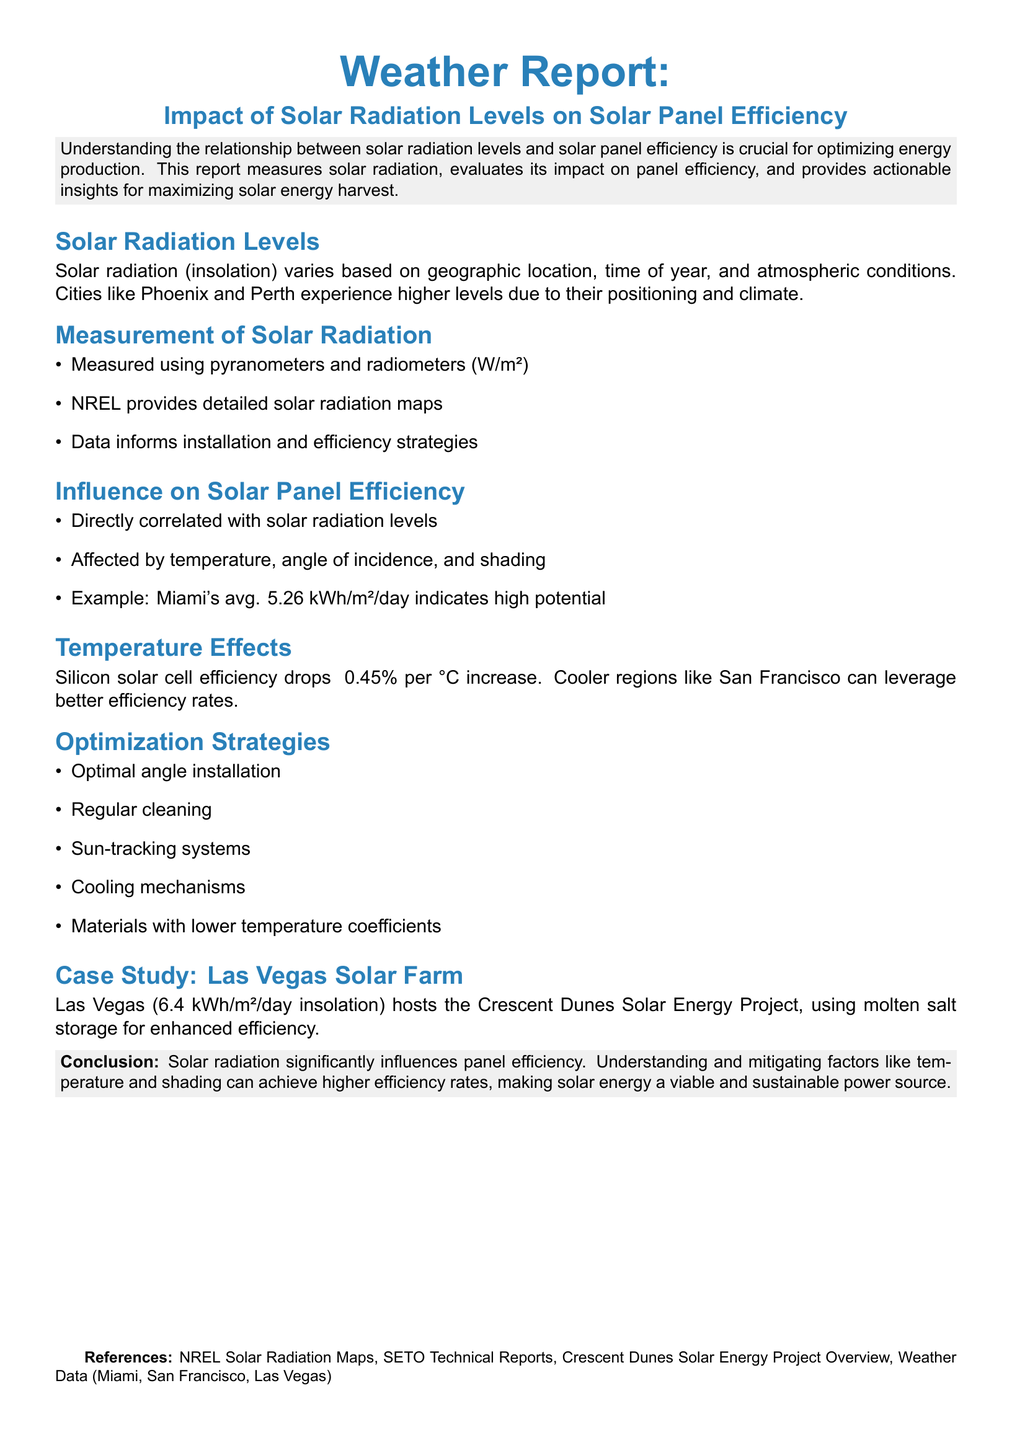What is the primary focus of the report? The report primarily focuses on understanding the relationship between solar radiation levels and solar panel efficiency.
Answer: Solar radiation levels and solar panel efficiency What measurement instruments are used for solar radiation? The document states that solar radiation is measured using pyranometers and radiometers.
Answer: Pyranometers and radiometers Which city has an average insolation of 5.26 kWh/m²/day? The report mentions that Miami's average insolation indicates high potential for solar energy.
Answer: Miami What is the efficiency drop of silicon solar cells per degree Celsius? The report states that silicon solar cell efficiency drops approximately 0.45% per °C increase.
Answer: 0.45% What is one optimization strategy mentioned in the report? One of the optimization strategies mentioned is regular cleaning of solar panels.
Answer: Regular cleaning How does temperature affect solar panel efficiency? The document explains that temperature affects efficiency, with a specific drop in cells as it increases.
Answer: Drops efficiency What is the name of the solar energy project mentioned in Las Vegas? The report references the Crescent Dunes Solar Energy Project in Las Vegas.
Answer: Crescent Dunes Solar Energy Project What color is used for section headings in the report? The heading color defined in the report is startup blue for section headings.
Answer: Startup blue Which geographic locations are highlighted as having high solar radiation levels? The report highlights cities like Phoenix and Perth as having higher solar radiation levels.
Answer: Phoenix and Perth 